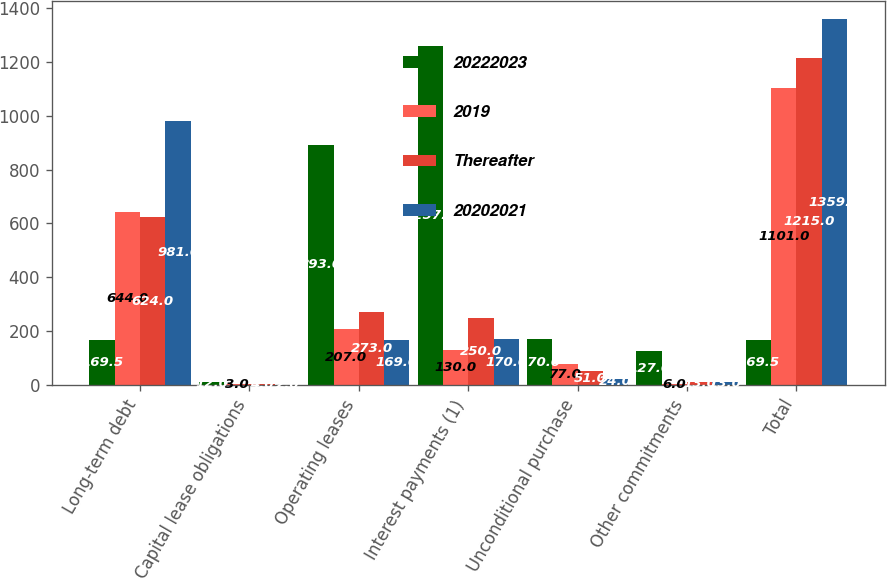Convert chart to OTSL. <chart><loc_0><loc_0><loc_500><loc_500><stacked_bar_chart><ecel><fcel>Long-term debt<fcel>Capital lease obligations<fcel>Operating leases<fcel>Interest payments (1)<fcel>Unconditional purchase<fcel>Other commitments<fcel>Total<nl><fcel>20222023<fcel>169.5<fcel>12<fcel>893<fcel>1257<fcel>170<fcel>127<fcel>169.5<nl><fcel>2019<fcel>644<fcel>3<fcel>207<fcel>130<fcel>77<fcel>6<fcel>1101<nl><fcel>Thereafter<fcel>624<fcel>4<fcel>273<fcel>250<fcel>51<fcel>13<fcel>1215<nl><fcel>20202021<fcel>981<fcel>2<fcel>169<fcel>170<fcel>24<fcel>13<fcel>1359<nl></chart> 